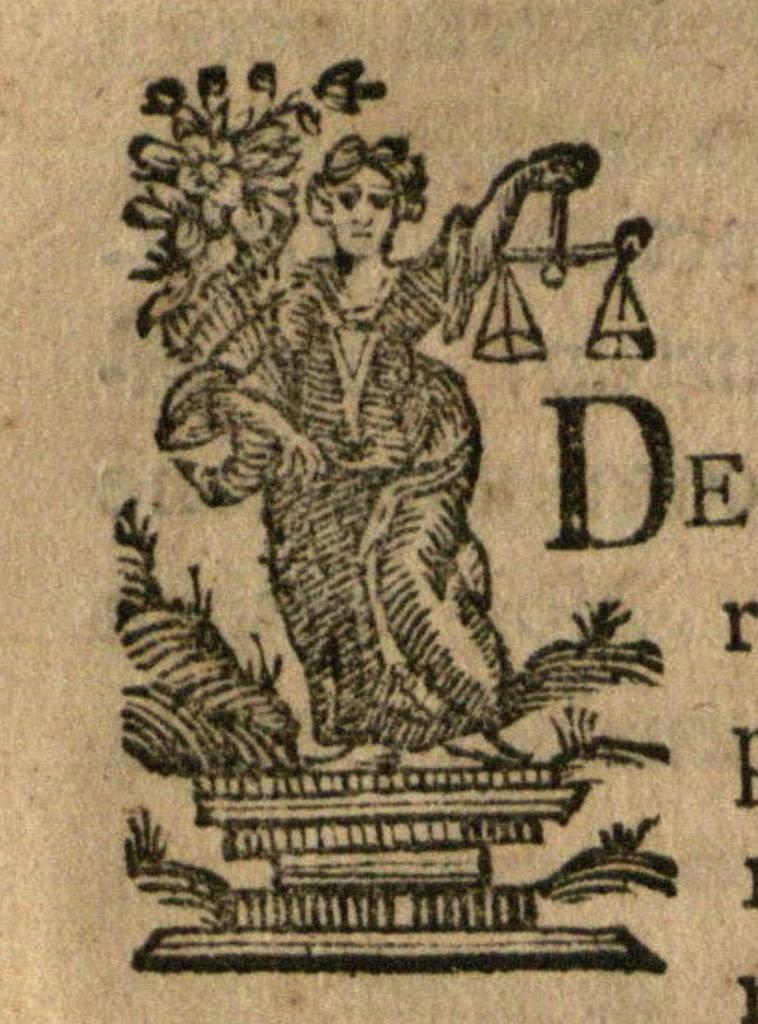What is the big letter?
Give a very brief answer. D. What is the second letter?
Ensure brevity in your answer.  E. 